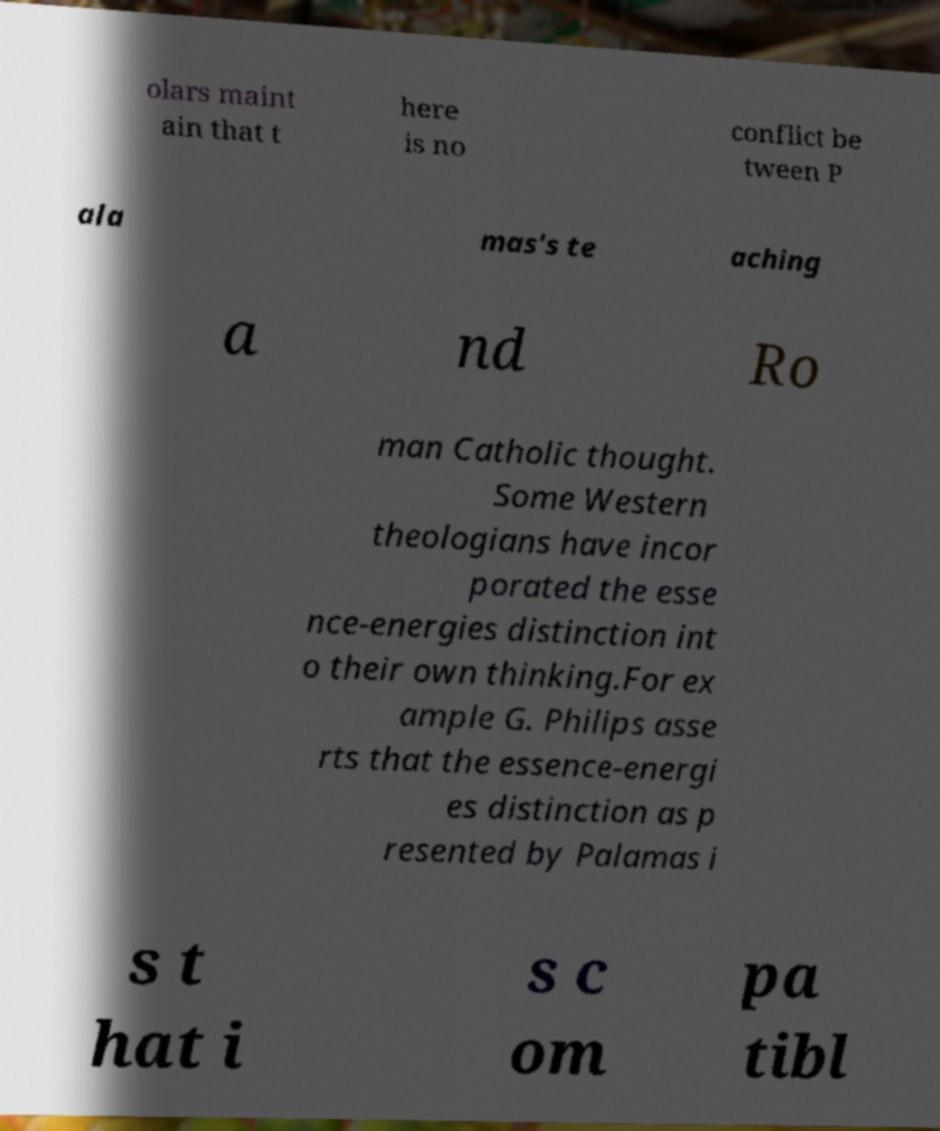For documentation purposes, I need the text within this image transcribed. Could you provide that? olars maint ain that t here is no conflict be tween P ala mas's te aching a nd Ro man Catholic thought. Some Western theologians have incor porated the esse nce-energies distinction int o their own thinking.For ex ample G. Philips asse rts that the essence-energi es distinction as p resented by Palamas i s t hat i s c om pa tibl 